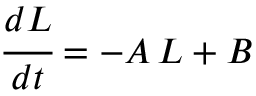Convert formula to latex. <formula><loc_0><loc_0><loc_500><loc_500>\cfrac { d L } { d t } = - A \, L + B</formula> 